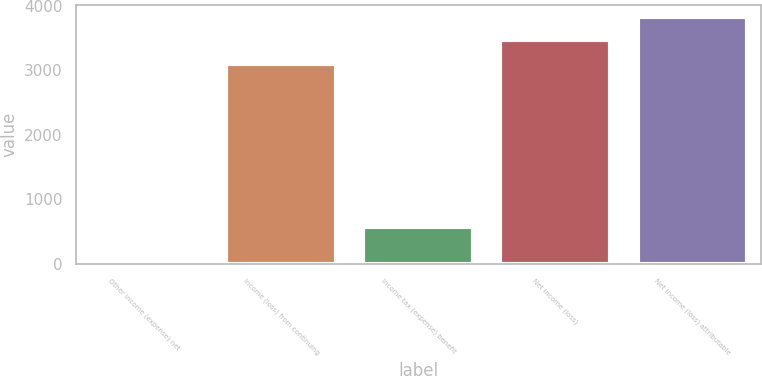<chart> <loc_0><loc_0><loc_500><loc_500><bar_chart><fcel>Other income (expense) net<fcel>Income (loss) from continuing<fcel>Income tax (expense) benefit<fcel>Net income (loss)<fcel>Net income (loss) attributable<nl><fcel>48<fcel>3103<fcel>567<fcel>3465.2<fcel>3827.4<nl></chart> 